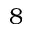<formula> <loc_0><loc_0><loc_500><loc_500>8</formula> 